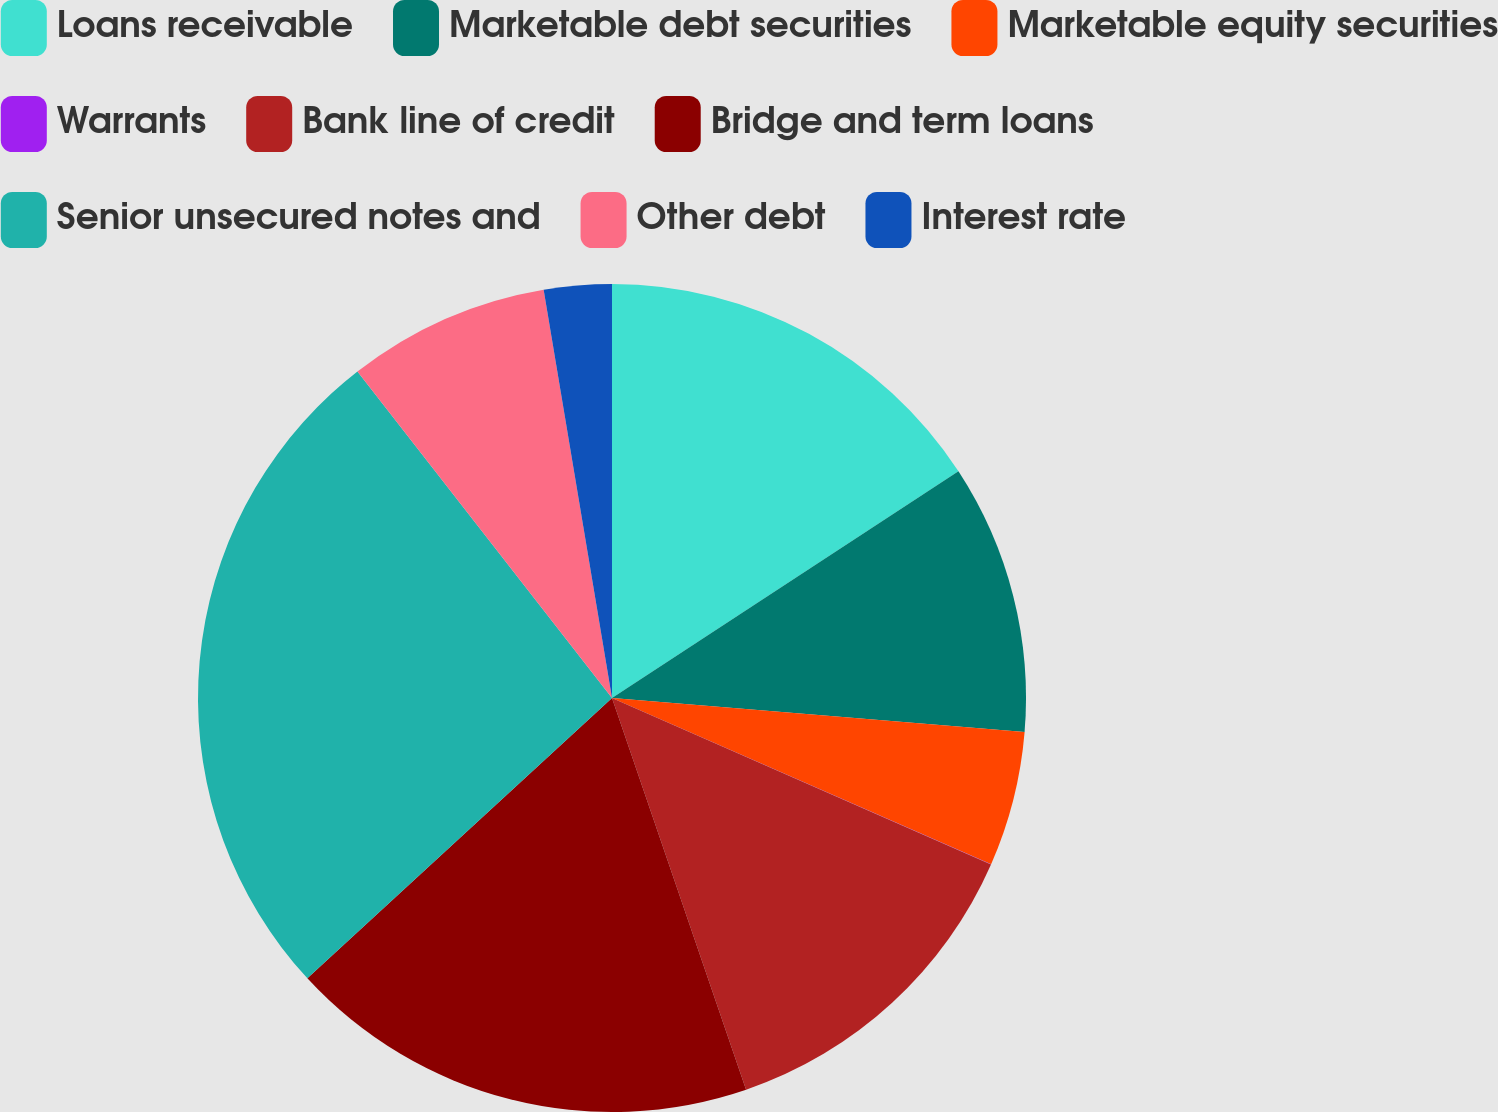Convert chart. <chart><loc_0><loc_0><loc_500><loc_500><pie_chart><fcel>Loans receivable<fcel>Marketable debt securities<fcel>Marketable equity securities<fcel>Warrants<fcel>Bank line of credit<fcel>Bridge and term loans<fcel>Senior unsecured notes and<fcel>Other debt<fcel>Interest rate<nl><fcel>15.78%<fcel>10.53%<fcel>5.27%<fcel>0.01%<fcel>13.16%<fcel>18.41%<fcel>26.3%<fcel>7.9%<fcel>2.64%<nl></chart> 